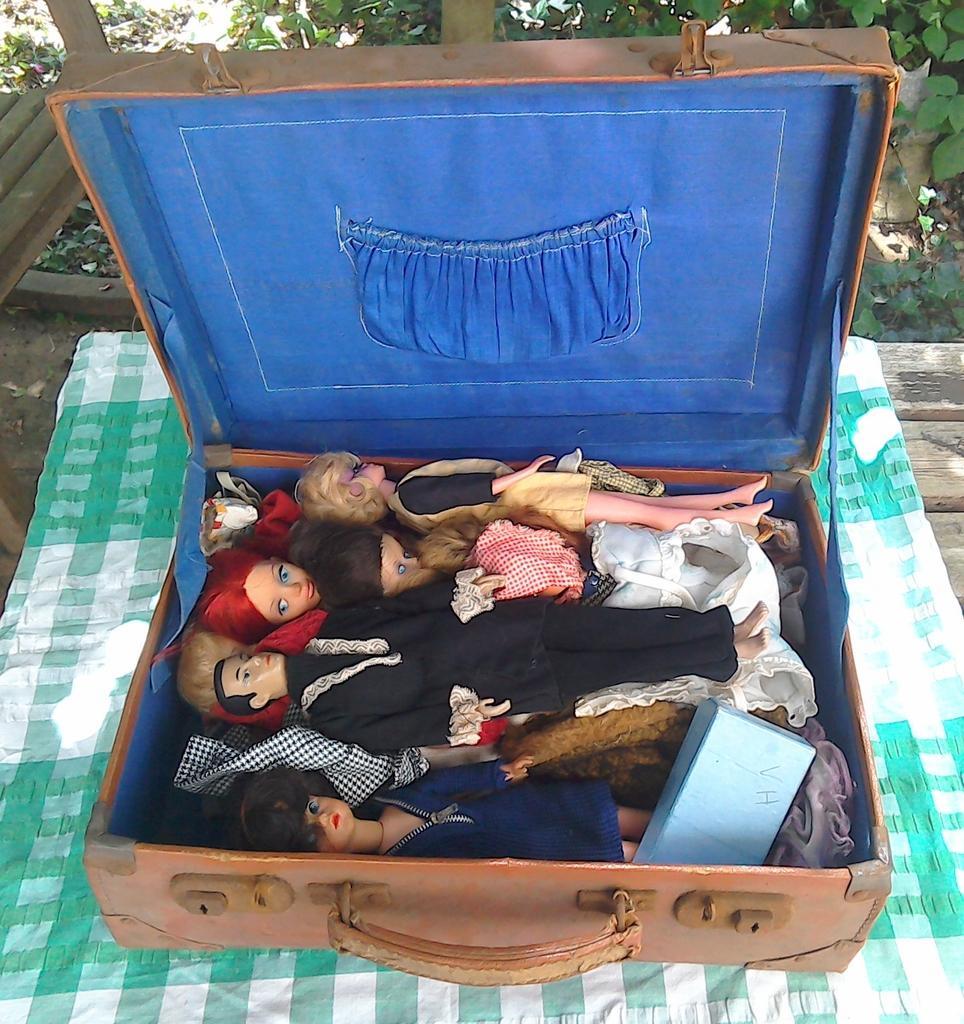Can you describe this image briefly? Here we can see a briefcase and toys in it, and here is the cloth, and at back here are the trees. 